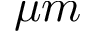<formula> <loc_0><loc_0><loc_500><loc_500>\mu m</formula> 